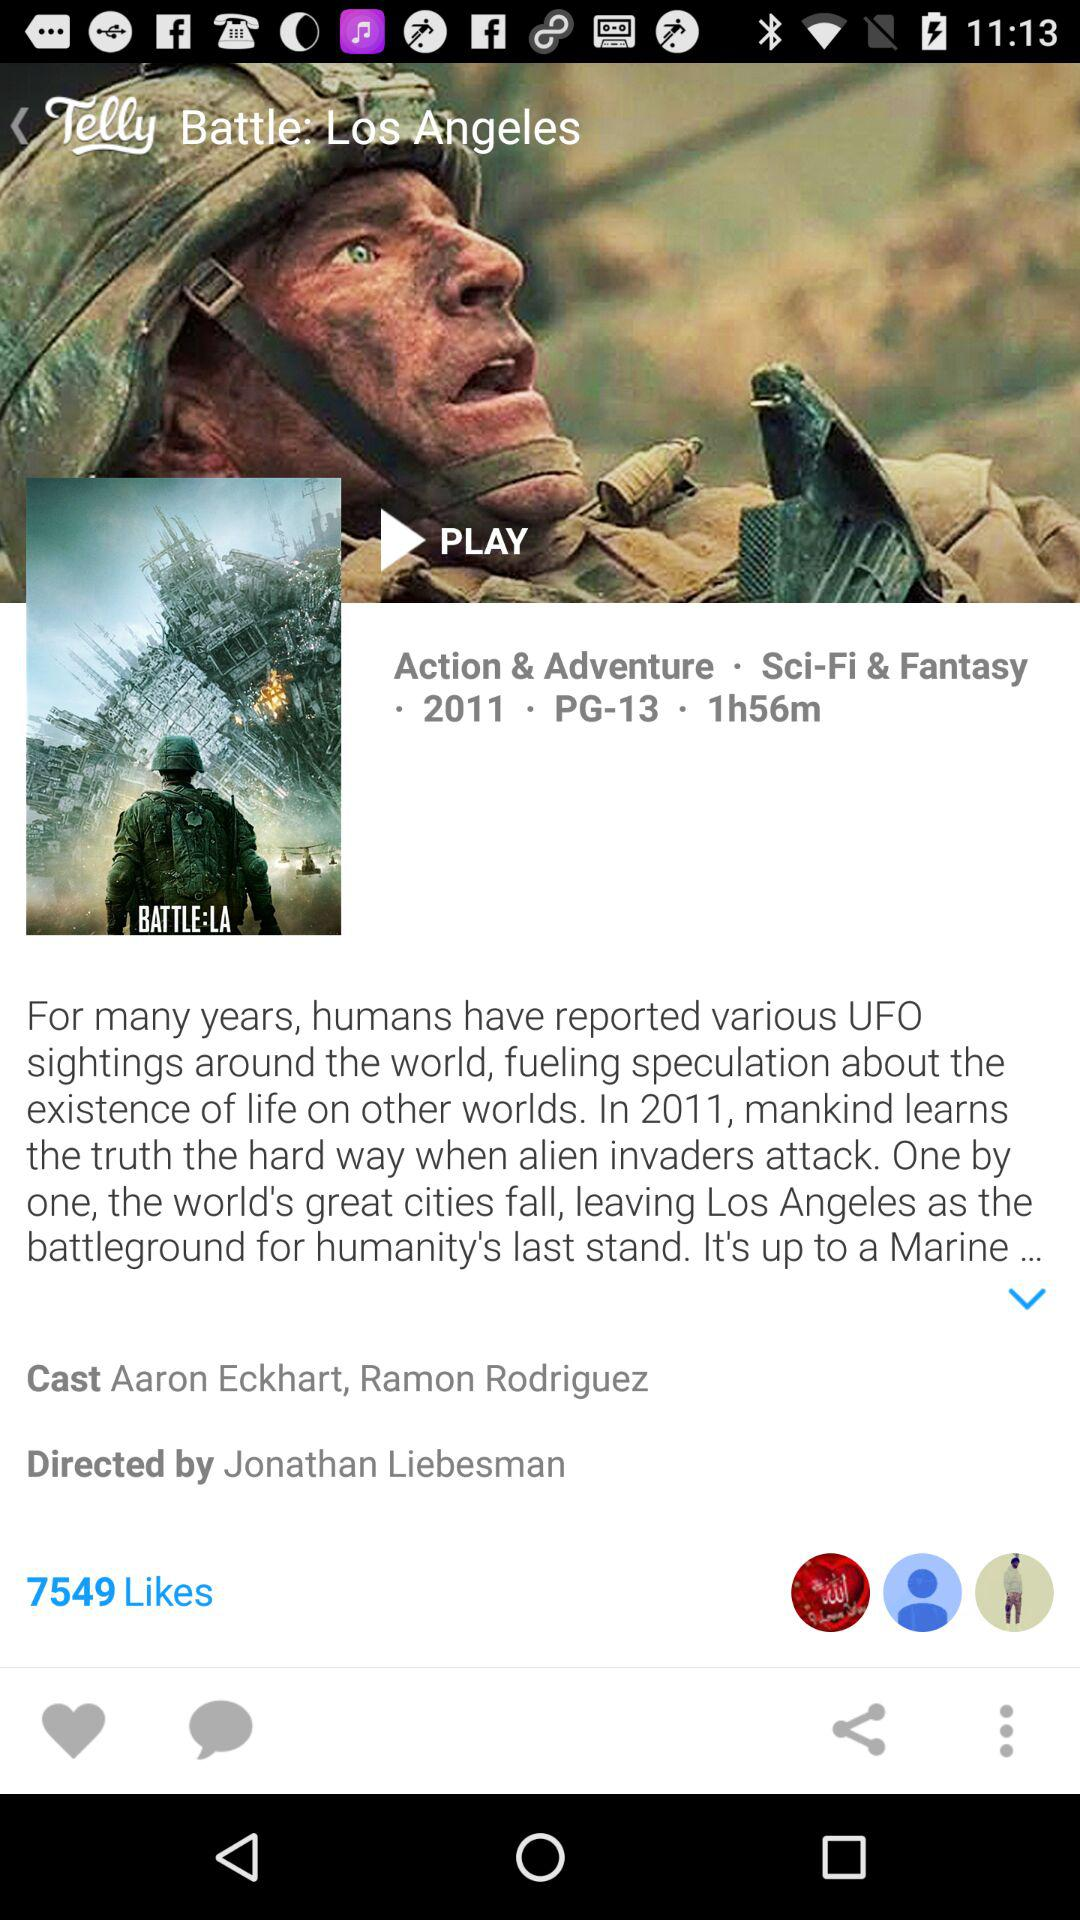What is the duration of the movie? The duration of the movie is 1 hour and 56 minutes. 